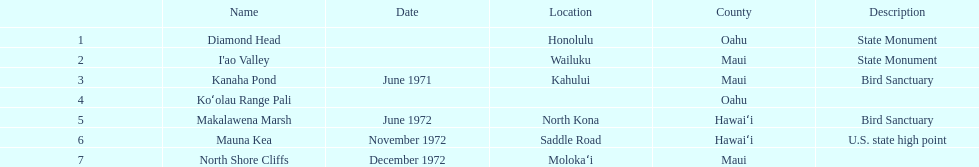How many images are listed? 6. Write the full table. {'header': ['', 'Name', 'Date', 'Location', 'County', 'Description'], 'rows': [['1', 'Diamond Head', '', 'Honolulu', 'Oahu', 'State Monument'], ['2', "I'ao Valley", '', 'Wailuku', 'Maui', 'State Monument'], ['3', 'Kanaha Pond', 'June 1971', 'Kahului', 'Maui', 'Bird Sanctuary'], ['4', 'Koʻolau Range Pali', '', '', 'Oahu', ''], ['5', 'Makalawena Marsh', 'June 1972', 'North Kona', 'Hawaiʻi', 'Bird Sanctuary'], ['6', 'Mauna Kea', 'November 1972', 'Saddle Road', 'Hawaiʻi', 'U.S. state high point'], ['7', 'North Shore Cliffs', 'December 1972', 'Molokaʻi', 'Maui', '']]} 